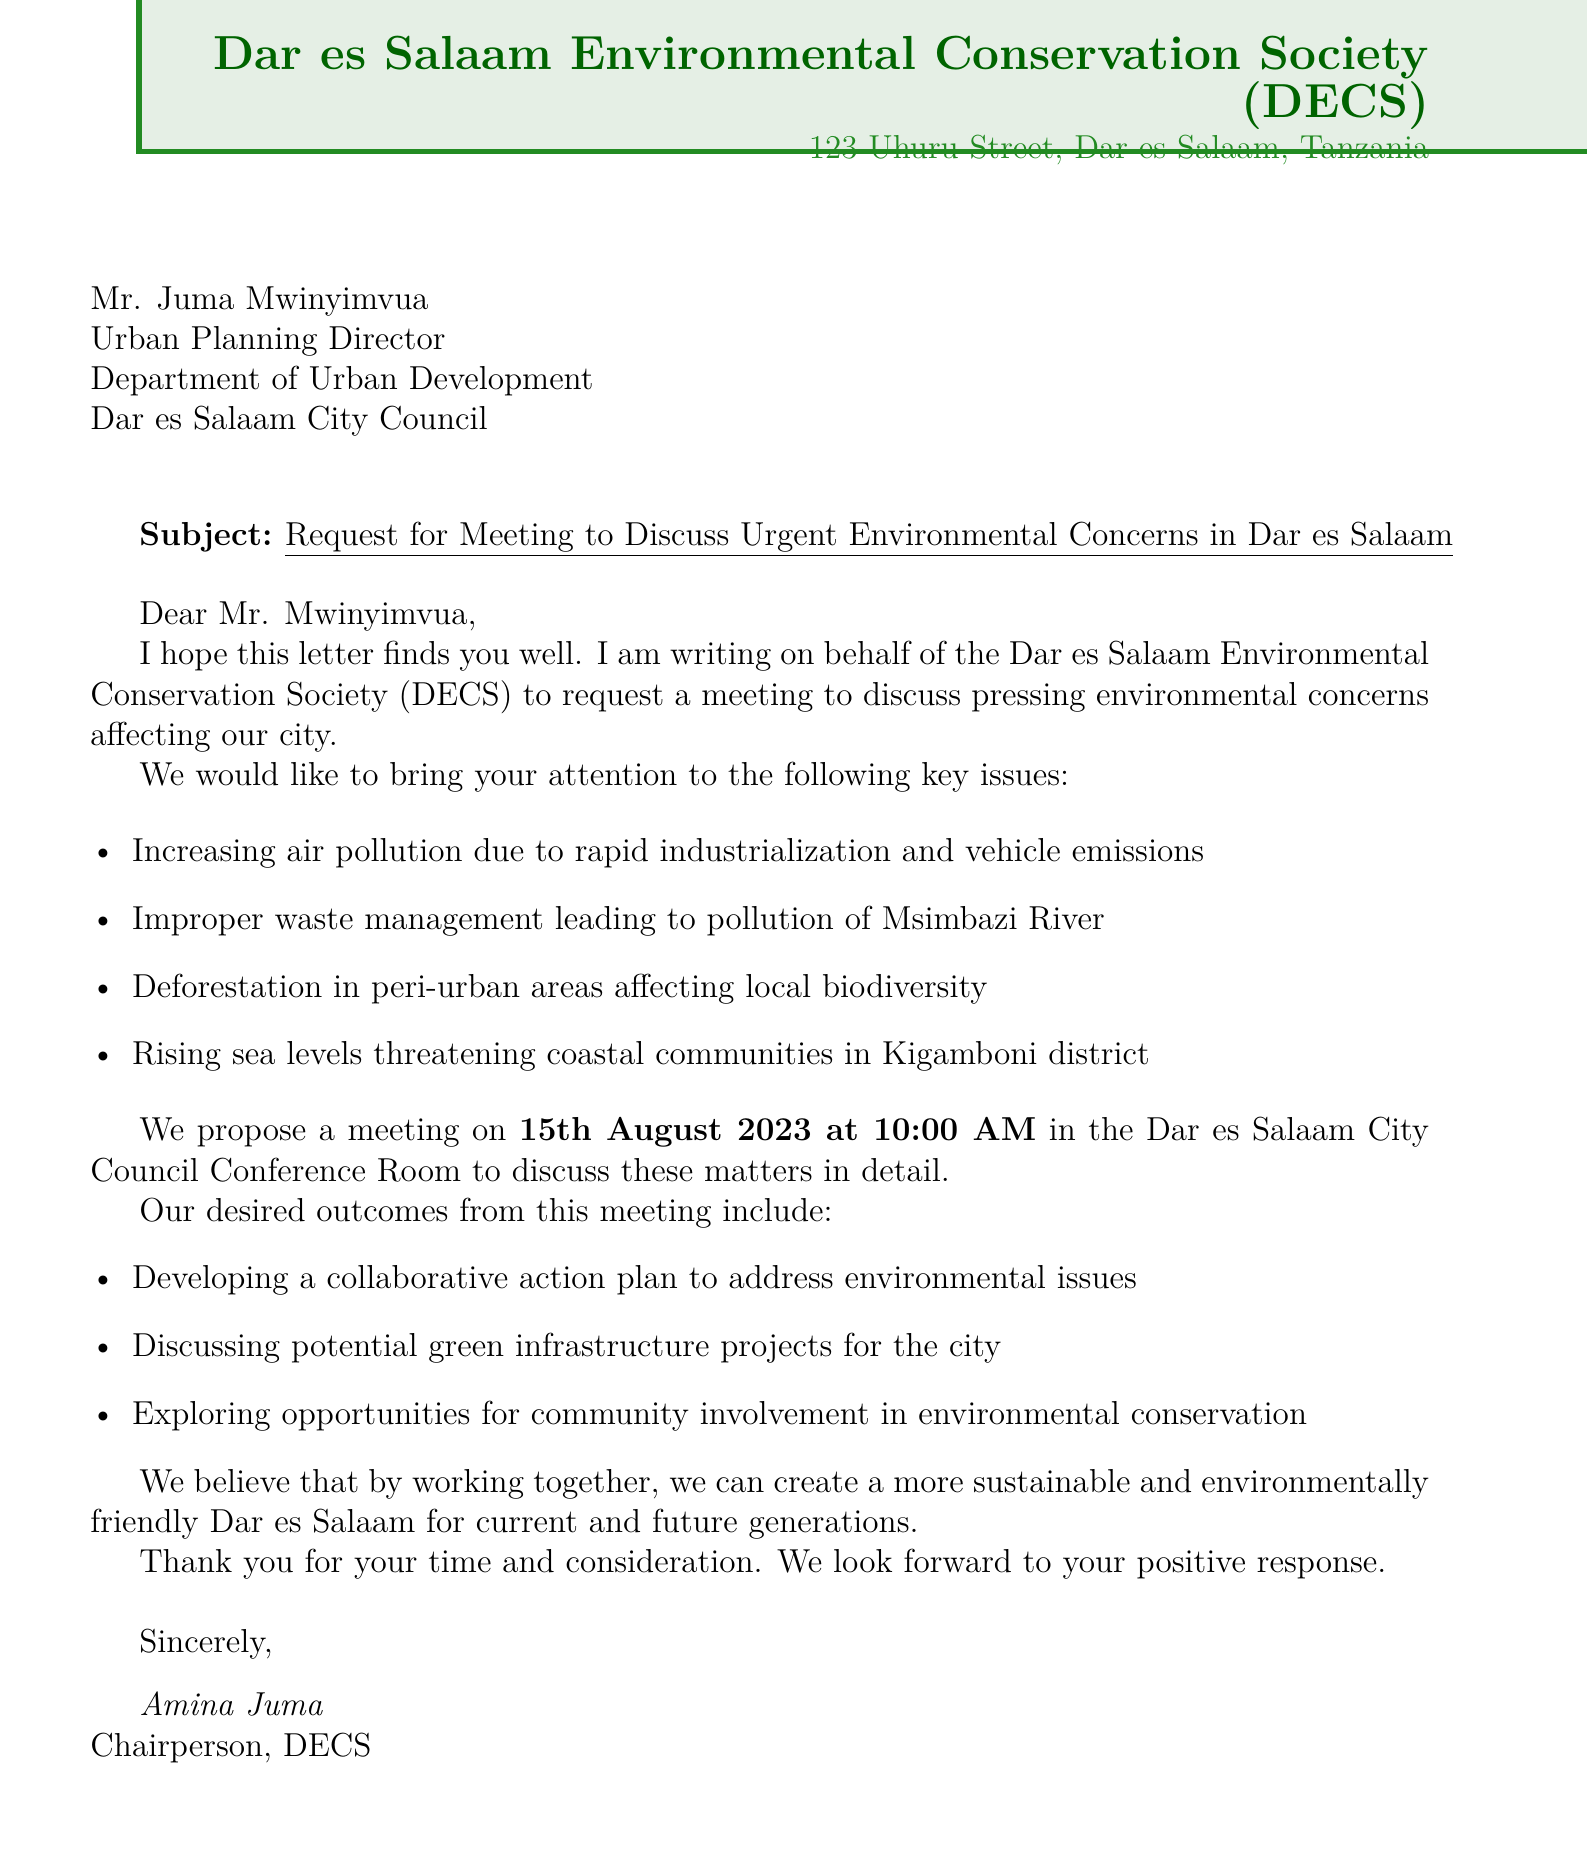What is the name of the organization sending the letter? The organization sending the letter is the one that initiated the request for a meeting on environmental concerns.
Answer: Dar es Salaam Environmental Conservation Society (DECS) Who is the contact person for the sending organization? The contact person mentioned in the letter is the representative of the sending organization who is responsible for communication.
Answer: Amina Juma What is the proposed date for the meeting? The proposed date needs to be gathered as it's essential for the scheduling of the meeting.
Answer: 15th August 2023 What is one key environmental issue mentioned in the letter? The letter outlines multiple environmental issues, and this requires recalling any of them specifically listed in the document.
Answer: Increasing air pollution due to rapid industrialization and vehicle emissions What is the desired outcome regarding community involvement? The letter outlines several desired outcomes for the meeting, which includes opportunities for the community.
Answer: Exploring opportunities for community involvement in environmental conservation How will the issues be addressed according to the letter? The letter proposes discussing a collaborative approach for handling the issues during the meeting.
Answer: Develop a collaborative action plan to address environmental issues In which venue is the meeting proposed to take place? The venue is mentioned in the letter's meeting details, which indicates where the meeting will occur.
Answer: Dar es Salaam City Council Conference Room What position does the recipient of the letter hold? The recipient’s title is specified in the letter, indicating their role within the local government.
Answer: Urban Planning Director 